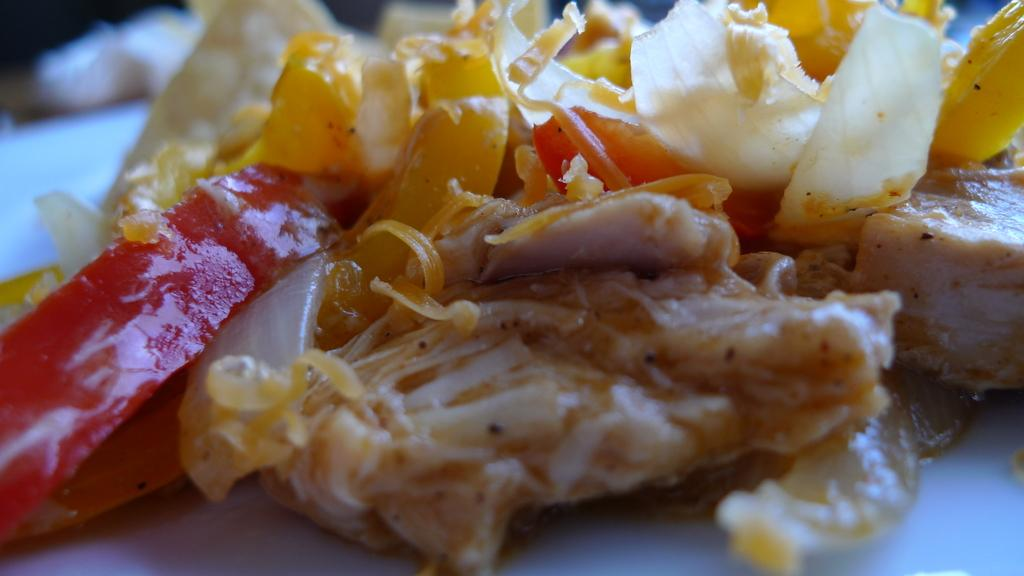What colors are present in the food in the image? The food in the image has red, yellow, and cream colors. What is the color of the surface on which the food is placed? The food is on a white surface. Can you describe the background of the image? The background of the image is blurred. What type of square object can be seen in the office in the image? There is no square object or office present in the image; it features food on a white surface with a blurred background. 